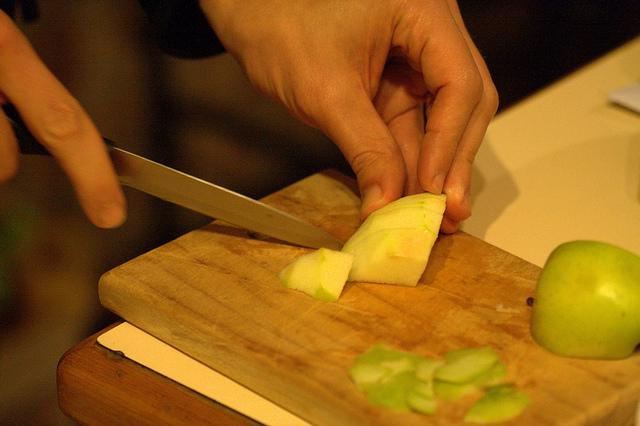What is this type of apple called? granny smith 